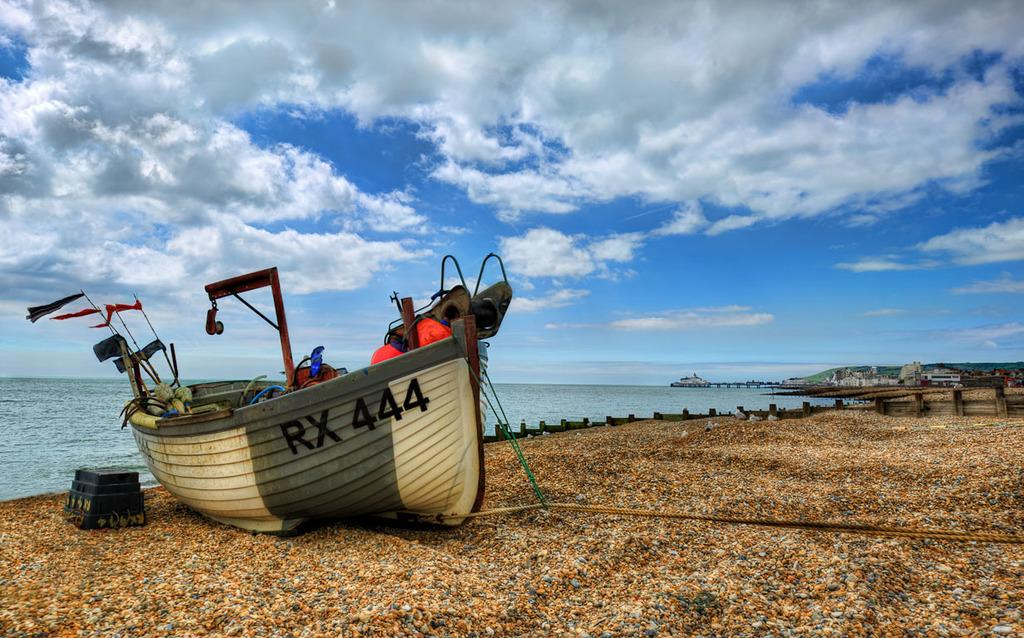<image>
Render a clear and concise summary of the photo. A boat sitting on the beach with the number RX 444 on the side. 